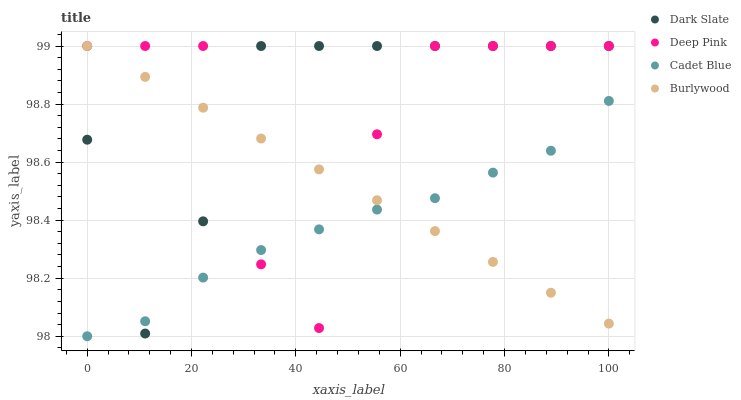Does Cadet Blue have the minimum area under the curve?
Answer yes or no. Yes. Does Dark Slate have the maximum area under the curve?
Answer yes or no. Yes. Does Deep Pink have the minimum area under the curve?
Answer yes or no. No. Does Deep Pink have the maximum area under the curve?
Answer yes or no. No. Is Burlywood the smoothest?
Answer yes or no. Yes. Is Deep Pink the roughest?
Answer yes or no. Yes. Is Dark Slate the smoothest?
Answer yes or no. No. Is Dark Slate the roughest?
Answer yes or no. No. Does Cadet Blue have the lowest value?
Answer yes or no. Yes. Does Dark Slate have the lowest value?
Answer yes or no. No. Does Burlywood have the highest value?
Answer yes or no. Yes. Does Burlywood intersect Dark Slate?
Answer yes or no. Yes. Is Burlywood less than Dark Slate?
Answer yes or no. No. Is Burlywood greater than Dark Slate?
Answer yes or no. No. 